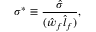<formula> <loc_0><loc_0><loc_500><loc_500>\sigma ^ { * } \equiv \frac { \hat { \sigma } } { ( \hat { w } _ { f } \hat { l } _ { f } ) } ,</formula> 